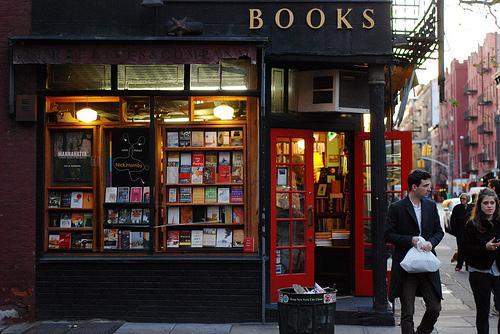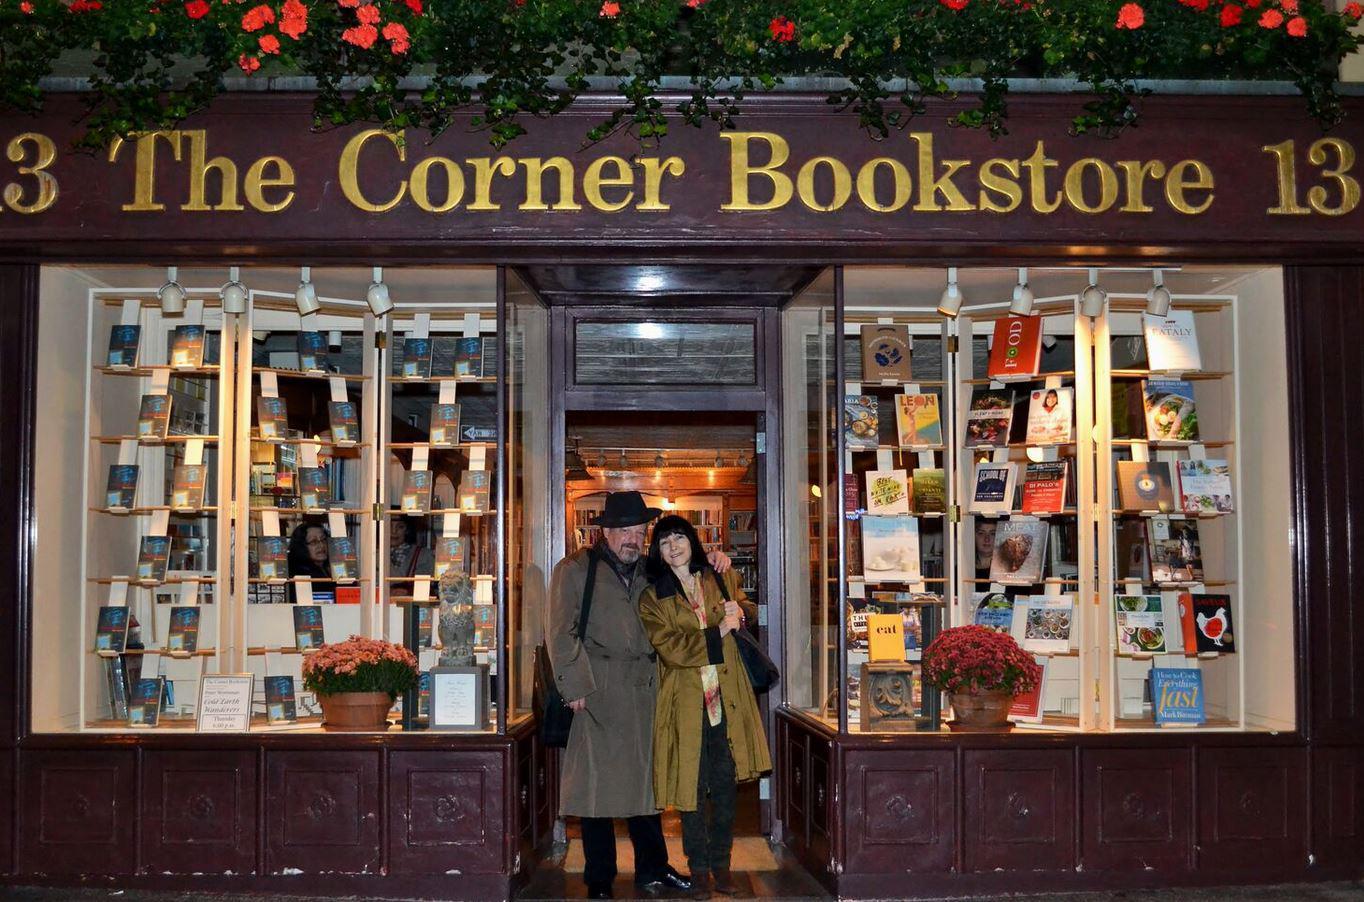The first image is the image on the left, the second image is the image on the right. Considering the images on both sides, is "In one of the image a red door is open." valid? Answer yes or no. Yes. The first image is the image on the left, the second image is the image on the right. Considering the images on both sides, is "The store in the right image has a red door with multiple windows built into the door." valid? Answer yes or no. No. 